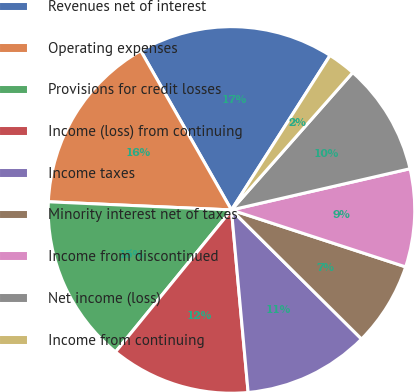<chart> <loc_0><loc_0><loc_500><loc_500><pie_chart><fcel>Revenues net of interest<fcel>Operating expenses<fcel>Provisions for credit losses<fcel>Income (loss) from continuing<fcel>Income taxes<fcel>Minority interest net of taxes<fcel>Income from discontinued<fcel>Net income (loss)<fcel>Income from continuing<nl><fcel>17.28%<fcel>16.05%<fcel>14.81%<fcel>12.35%<fcel>11.11%<fcel>7.41%<fcel>8.64%<fcel>9.88%<fcel>2.47%<nl></chart> 